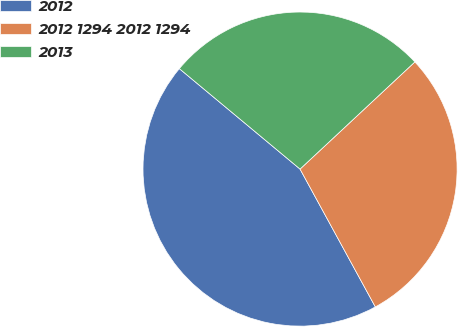Convert chart to OTSL. <chart><loc_0><loc_0><loc_500><loc_500><pie_chart><fcel>2012<fcel>2012 1294 2012 1294<fcel>2013<nl><fcel>44.0%<fcel>28.99%<fcel>27.0%<nl></chart> 